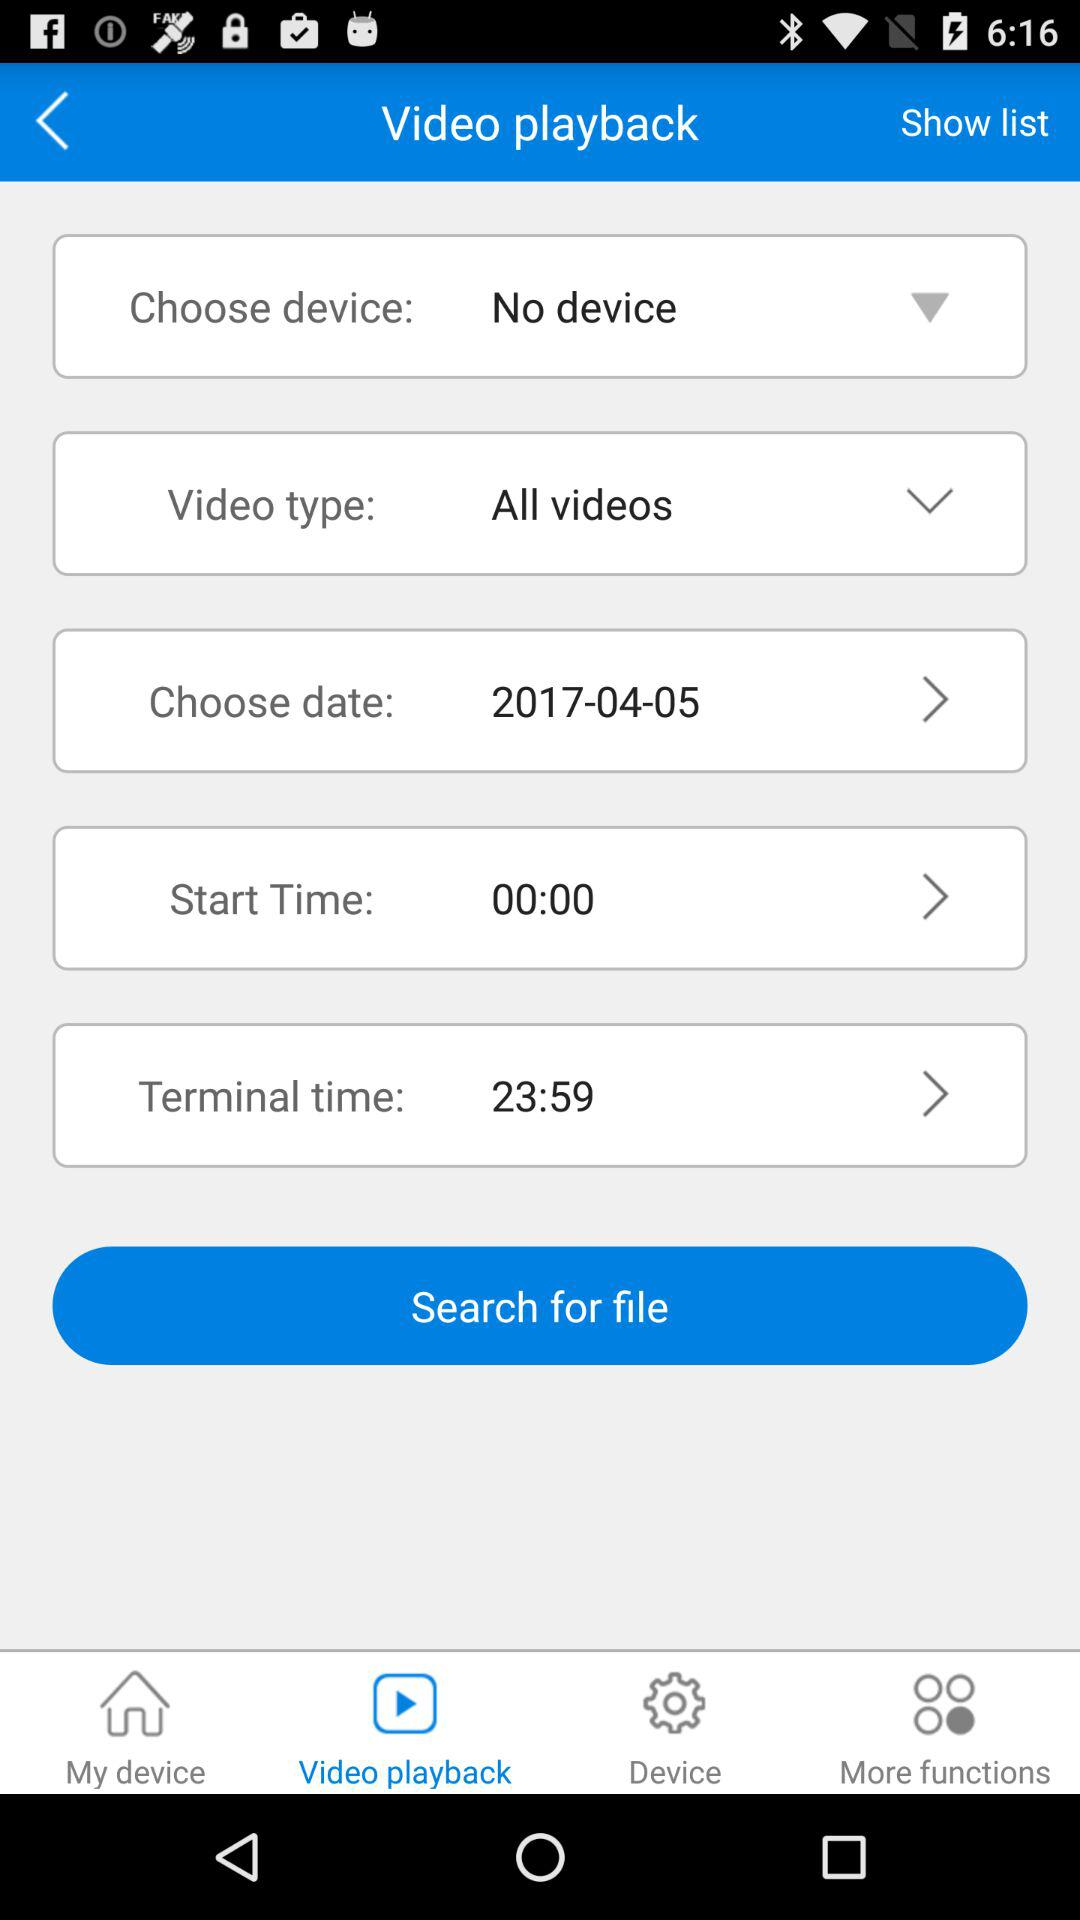What is the start time? The start time is 00:00. 